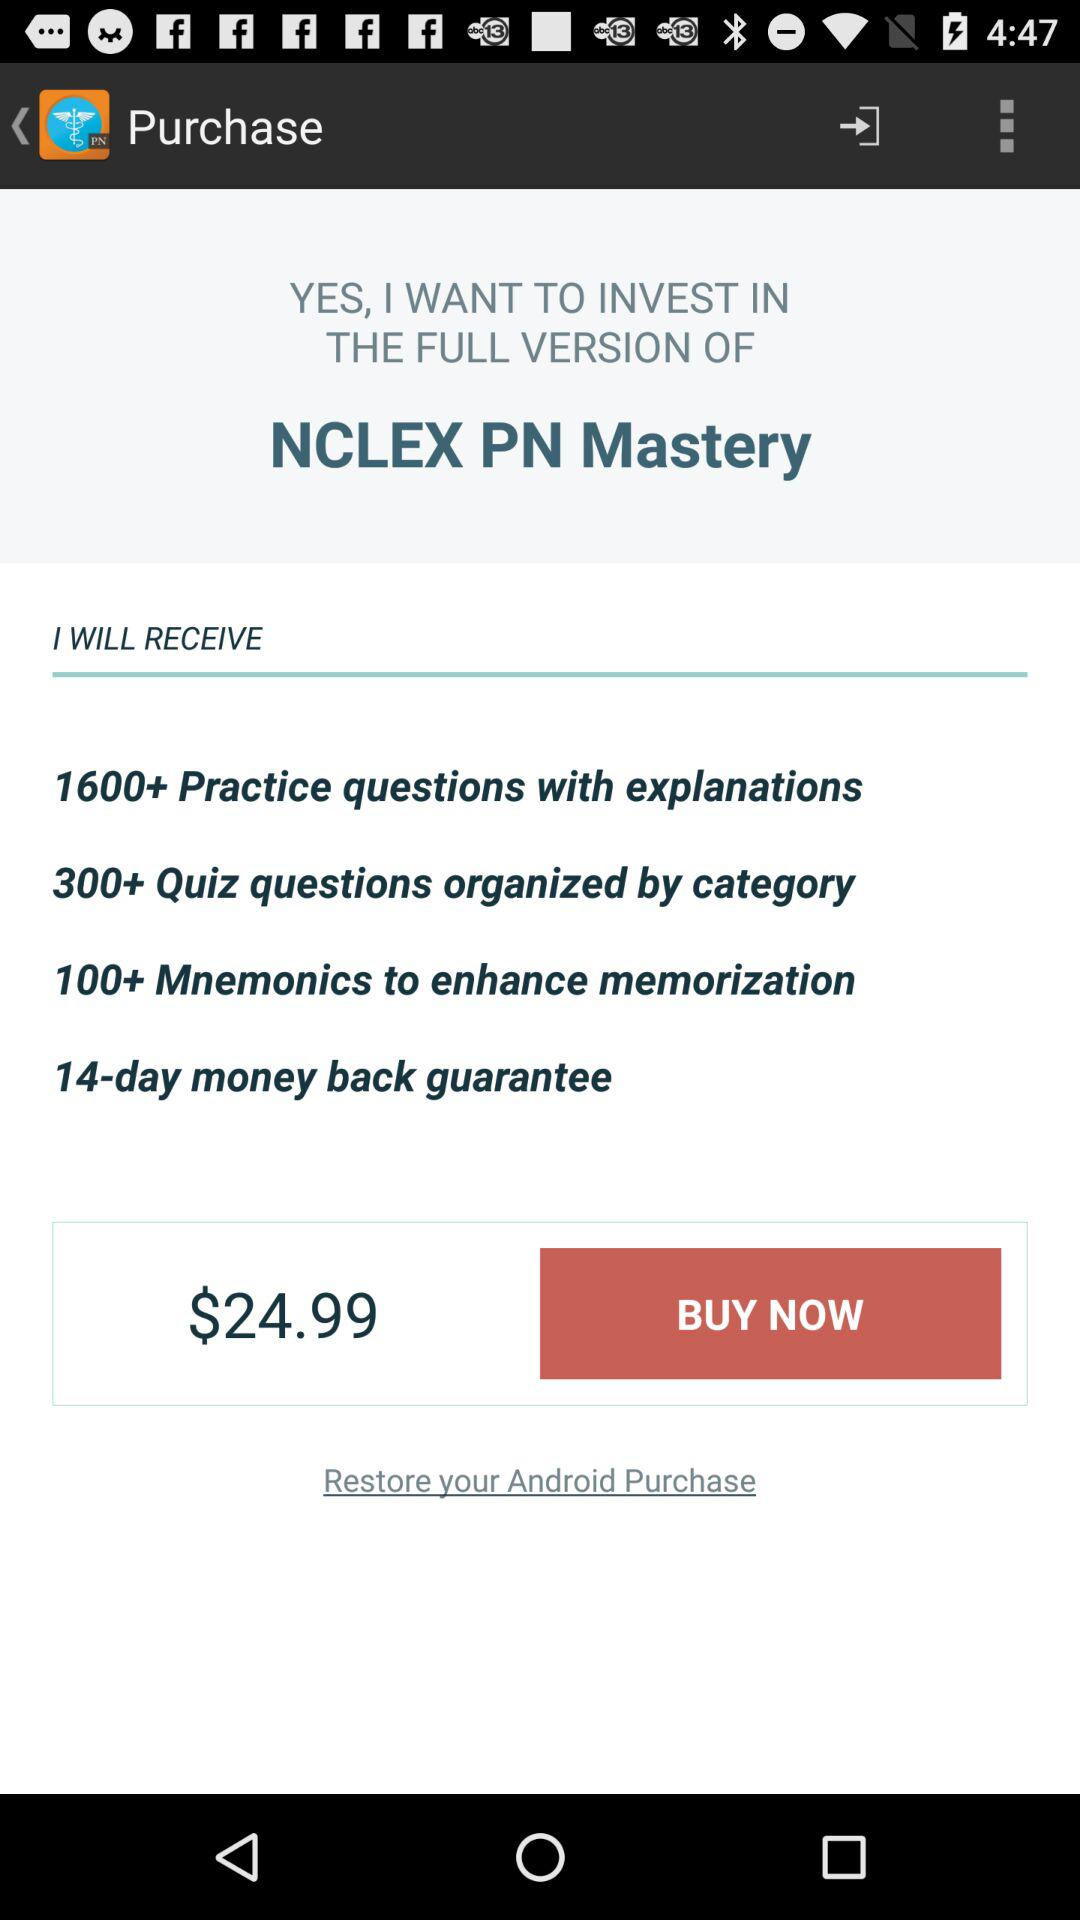What is the period of the money-back guarantee? The period is 14 days. 